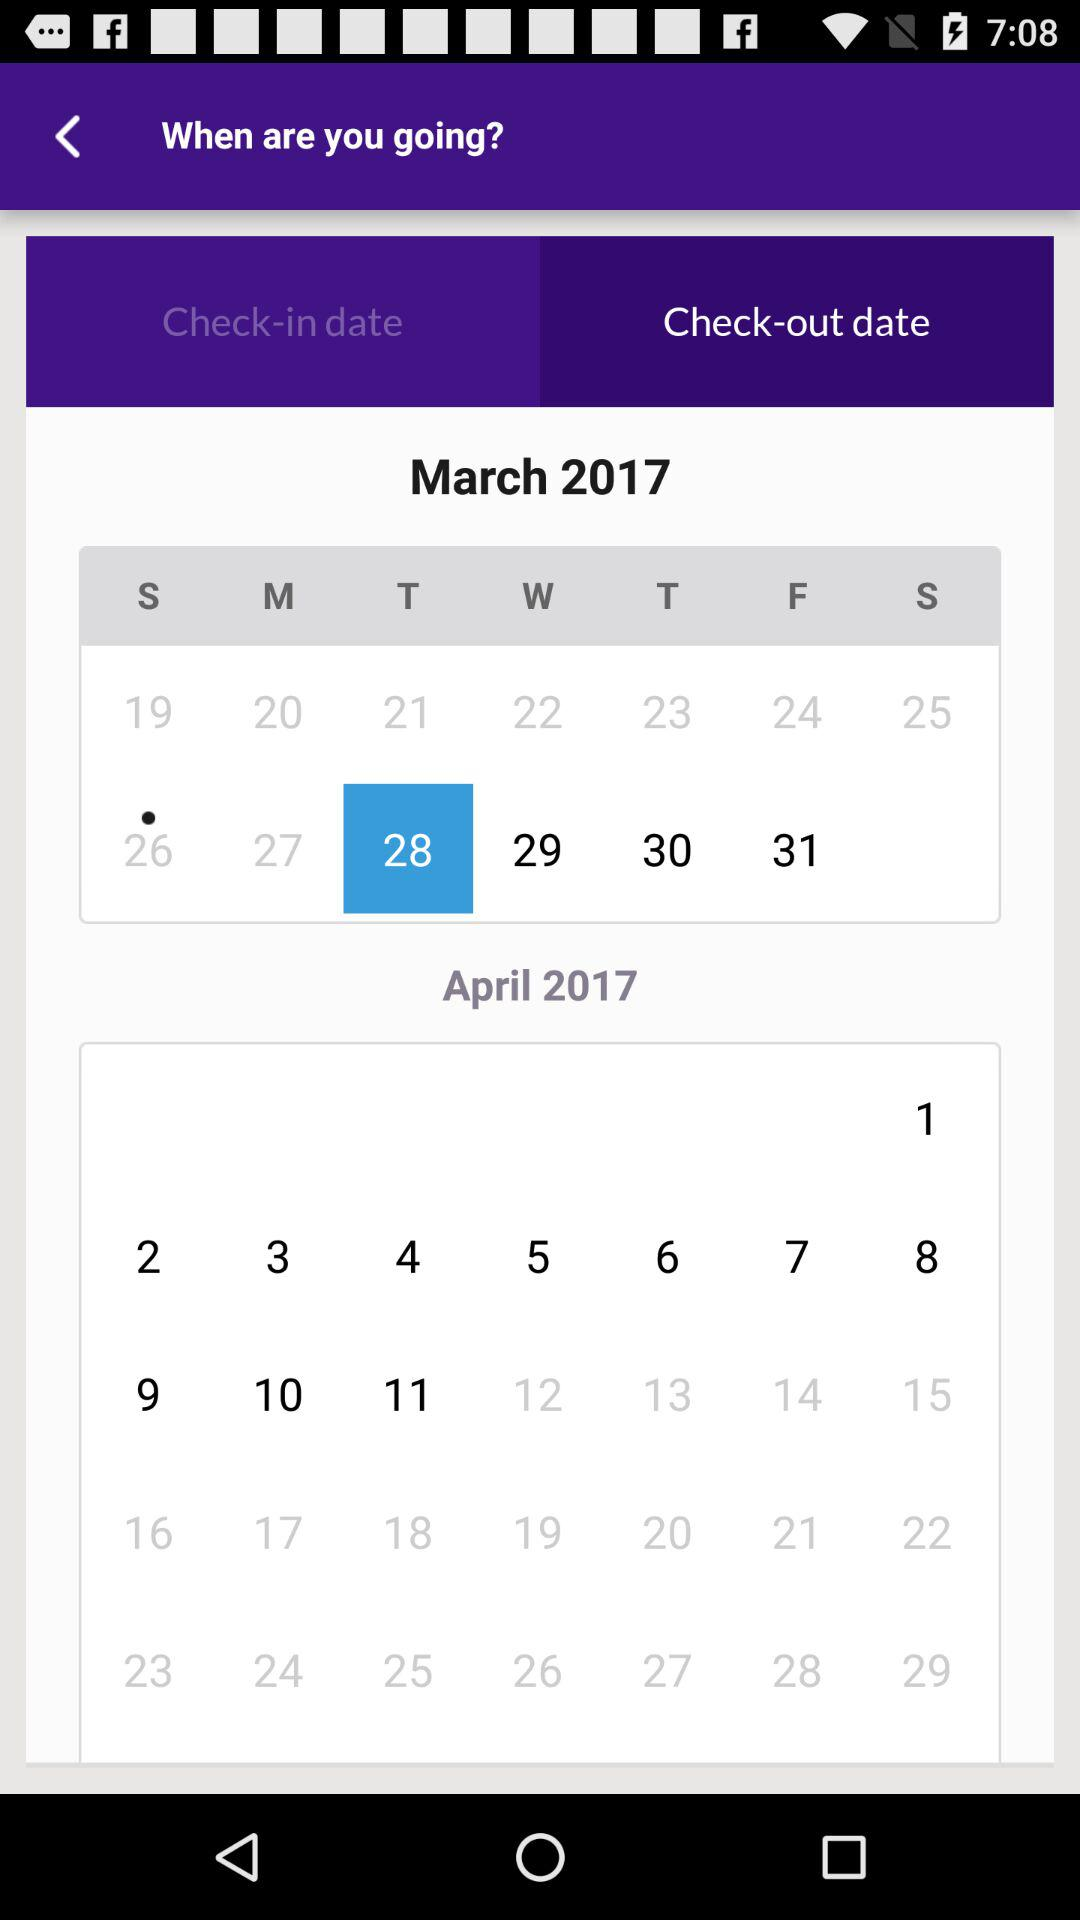What is the selected check-out date? The selected check-out date is March 28, 2017. 